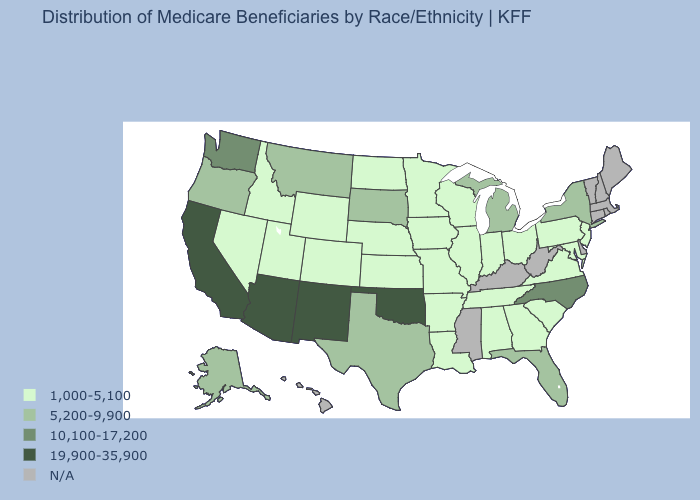Name the states that have a value in the range 19,900-35,900?
Be succinct. Arizona, California, New Mexico, Oklahoma. Which states have the lowest value in the USA?
Answer briefly. Alabama, Arkansas, Colorado, Georgia, Idaho, Illinois, Indiana, Iowa, Kansas, Louisiana, Maryland, Minnesota, Missouri, Nebraska, Nevada, New Jersey, North Dakota, Ohio, Pennsylvania, South Carolina, Tennessee, Utah, Virginia, Wisconsin, Wyoming. Which states have the lowest value in the USA?
Short answer required. Alabama, Arkansas, Colorado, Georgia, Idaho, Illinois, Indiana, Iowa, Kansas, Louisiana, Maryland, Minnesota, Missouri, Nebraska, Nevada, New Jersey, North Dakota, Ohio, Pennsylvania, South Carolina, Tennessee, Utah, Virginia, Wisconsin, Wyoming. What is the highest value in the USA?
Keep it brief. 19,900-35,900. Which states have the lowest value in the USA?
Answer briefly. Alabama, Arkansas, Colorado, Georgia, Idaho, Illinois, Indiana, Iowa, Kansas, Louisiana, Maryland, Minnesota, Missouri, Nebraska, Nevada, New Jersey, North Dakota, Ohio, Pennsylvania, South Carolina, Tennessee, Utah, Virginia, Wisconsin, Wyoming. What is the value of Maryland?
Short answer required. 1,000-5,100. What is the highest value in states that border Massachusetts?
Short answer required. 5,200-9,900. What is the value of Kansas?
Be succinct. 1,000-5,100. Name the states that have a value in the range 10,100-17,200?
Give a very brief answer. North Carolina, Washington. Does the map have missing data?
Answer briefly. Yes. Does the first symbol in the legend represent the smallest category?
Give a very brief answer. Yes. What is the value of Delaware?
Give a very brief answer. N/A. Does Oregon have the lowest value in the USA?
Give a very brief answer. No. What is the value of Delaware?
Concise answer only. N/A. 